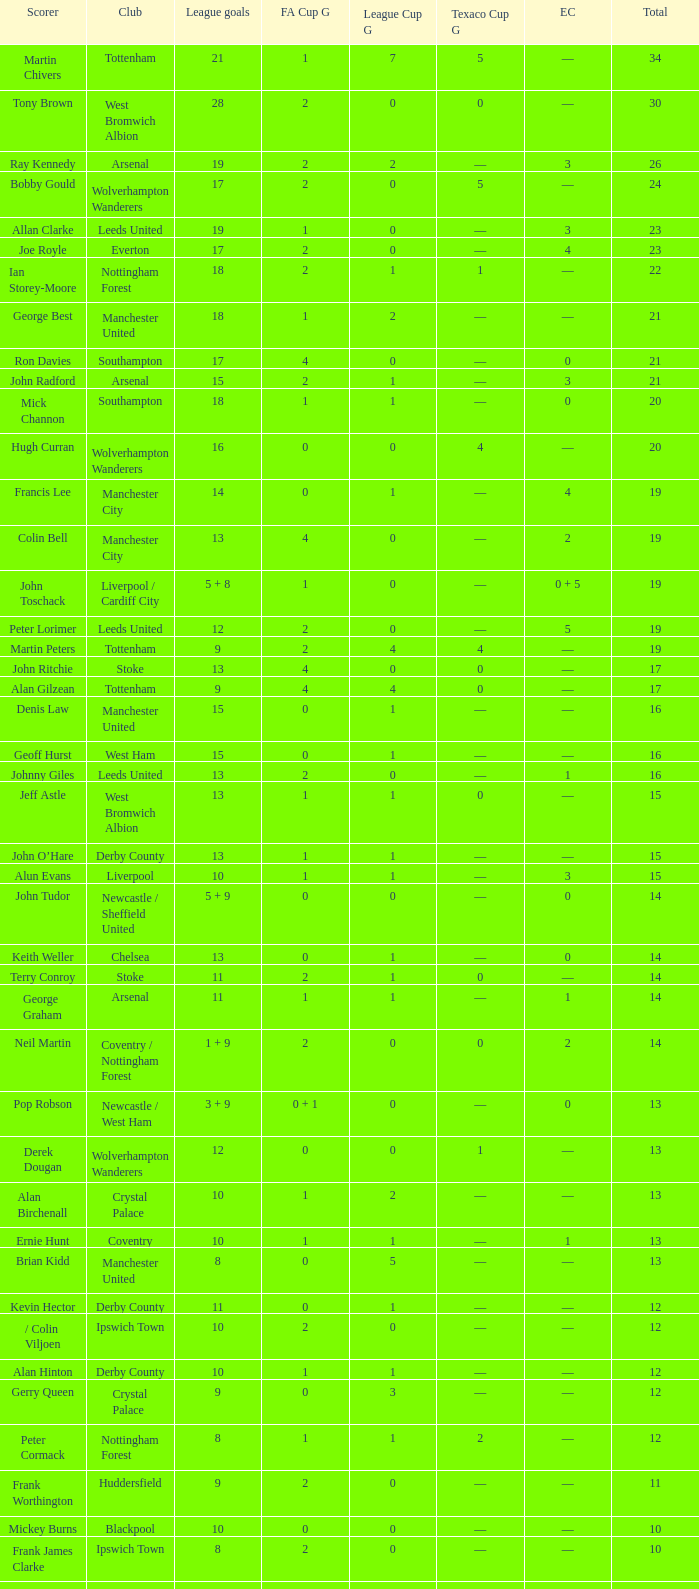What is the total number of Total, when Club is Leeds United, and when League Goals is 13? 1.0. 